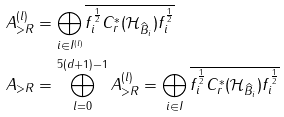Convert formula to latex. <formula><loc_0><loc_0><loc_500><loc_500>A _ { > R } ^ { ( l ) } & = \bigoplus _ { i \in I ^ { ( l ) } } \overline { f _ { i } ^ { \frac { 1 } { 2 } } C ^ { * } _ { r } ( \mathcal { H } _ { \widehat { B } _ { i } } ) f _ { i } ^ { \frac { 1 } { 2 } } } \\ A _ { > R } & = \bigoplus _ { l = 0 } ^ { 5 ( d + 1 ) - 1 } A _ { > R } ^ { ( l ) } = \bigoplus _ { i \in I } \overline { f _ { i } ^ { \frac { 1 } { 2 } } C ^ { * } _ { r } ( \mathcal { H } _ { \widehat { B } _ { i } } ) f _ { i } ^ { \frac { 1 } { 2 } } }</formula> 